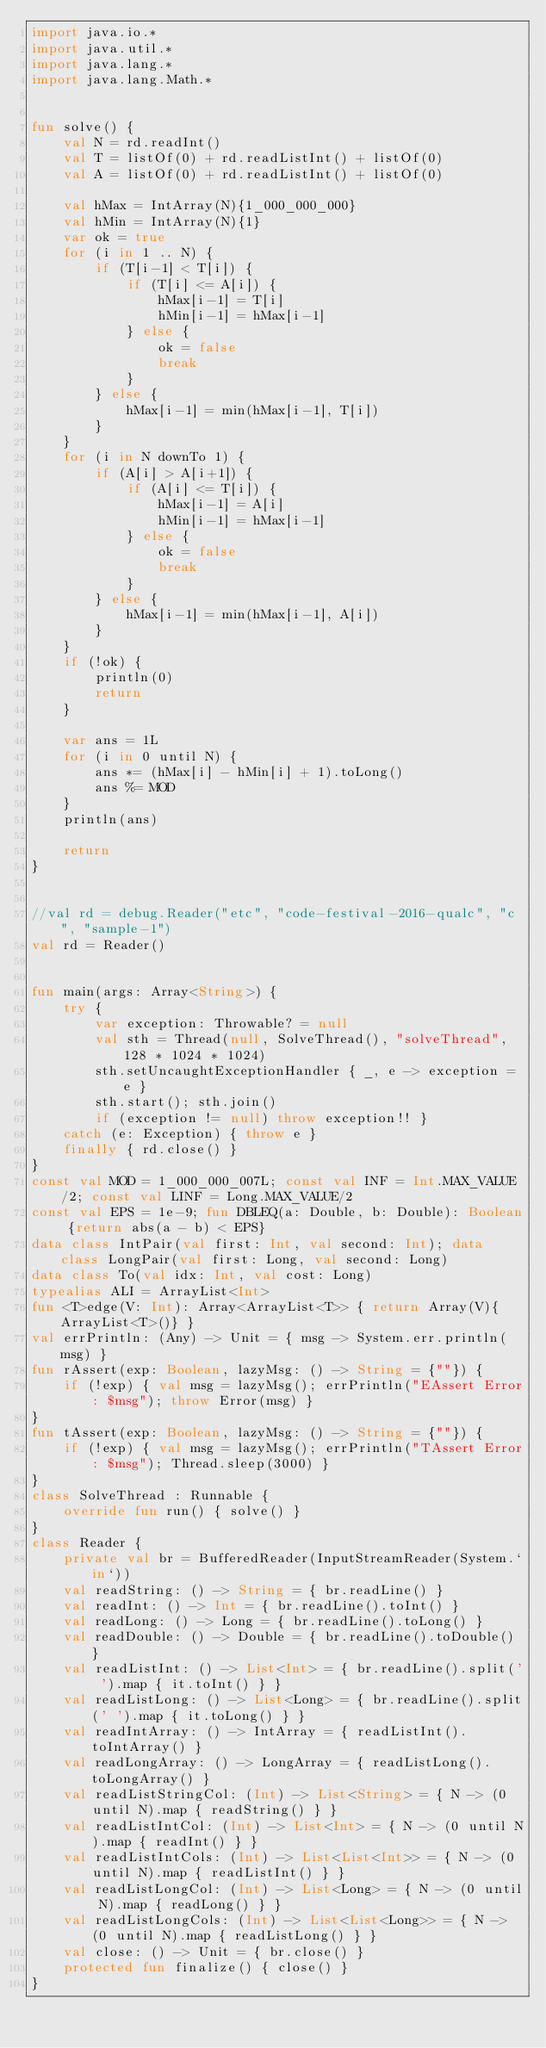Convert code to text. <code><loc_0><loc_0><loc_500><loc_500><_Kotlin_>import java.io.*
import java.util.*
import java.lang.*
import java.lang.Math.*


fun solve() {
    val N = rd.readInt()
    val T = listOf(0) + rd.readListInt() + listOf(0)
    val A = listOf(0) + rd.readListInt() + listOf(0)

    val hMax = IntArray(N){1_000_000_000}
    val hMin = IntArray(N){1}
    var ok = true
    for (i in 1 .. N) {
        if (T[i-1] < T[i]) {
            if (T[i] <= A[i]) {
                hMax[i-1] = T[i]
                hMin[i-1] = hMax[i-1]
            } else {
                ok = false
                break
            }
        } else {
            hMax[i-1] = min(hMax[i-1], T[i])
        }
    }
    for (i in N downTo 1) {
        if (A[i] > A[i+1]) {
            if (A[i] <= T[i]) {
                hMax[i-1] = A[i]
                hMin[i-1] = hMax[i-1]
            } else {
                ok = false
                break
            }
        } else {
            hMax[i-1] = min(hMax[i-1], A[i])
        }
    }
    if (!ok) {
        println(0)
        return
    }

    var ans = 1L
    for (i in 0 until N) {
        ans *= (hMax[i] - hMin[i] + 1).toLong()
        ans %= MOD
    }
    println(ans)

    return
}


//val rd = debug.Reader("etc", "code-festival-2016-qualc", "c", "sample-1")
val rd = Reader()


fun main(args: Array<String>) {
    try {
        var exception: Throwable? = null
        val sth = Thread(null, SolveThread(), "solveThread", 128 * 1024 * 1024)
        sth.setUncaughtExceptionHandler { _, e -> exception = e }
        sth.start(); sth.join()
        if (exception != null) throw exception!! }
    catch (e: Exception) { throw e }
    finally { rd.close() }
}
const val MOD = 1_000_000_007L; const val INF = Int.MAX_VALUE/2; const val LINF = Long.MAX_VALUE/2
const val EPS = 1e-9; fun DBLEQ(a: Double, b: Double): Boolean {return abs(a - b) < EPS}
data class IntPair(val first: Int, val second: Int); data class LongPair(val first: Long, val second: Long)
data class To(val idx: Int, val cost: Long)
typealias ALI = ArrayList<Int>
fun <T>edge(V: Int): Array<ArrayList<T>> { return Array(V){ArrayList<T>()} }
val errPrintln: (Any) -> Unit = { msg -> System.err.println(msg) }
fun rAssert(exp: Boolean, lazyMsg: () -> String = {""}) {
    if (!exp) { val msg = lazyMsg(); errPrintln("EAssert Error: $msg"); throw Error(msg) }
}
fun tAssert(exp: Boolean, lazyMsg: () -> String = {""}) {
    if (!exp) { val msg = lazyMsg(); errPrintln("TAssert Error: $msg"); Thread.sleep(3000) }
}
class SolveThread : Runnable {
    override fun run() { solve() }
}
class Reader {
    private val br = BufferedReader(InputStreamReader(System.`in`))
    val readString: () -> String = { br.readLine() }
    val readInt: () -> Int = { br.readLine().toInt() }
    val readLong: () -> Long = { br.readLine().toLong() }
    val readDouble: () -> Double = { br.readLine().toDouble() }
    val readListInt: () -> List<Int> = { br.readLine().split(' ').map { it.toInt() } }
    val readListLong: () -> List<Long> = { br.readLine().split(' ').map { it.toLong() } }
    val readIntArray: () -> IntArray = { readListInt().toIntArray() }
    val readLongArray: () -> LongArray = { readListLong().toLongArray() }
    val readListStringCol: (Int) -> List<String> = { N -> (0 until N).map { readString() } }
    val readListIntCol: (Int) -> List<Int> = { N -> (0 until N).map { readInt() } }
    val readListIntCols: (Int) -> List<List<Int>> = { N -> (0 until N).map { readListInt() } }
    val readListLongCol: (Int) -> List<Long> = { N -> (0 until N).map { readLong() } }
    val readListLongCols: (Int) -> List<List<Long>> = { N -> (0 until N).map { readListLong() } }
    val close: () -> Unit = { br.close() }
    protected fun finalize() { close() }
}
</code> 